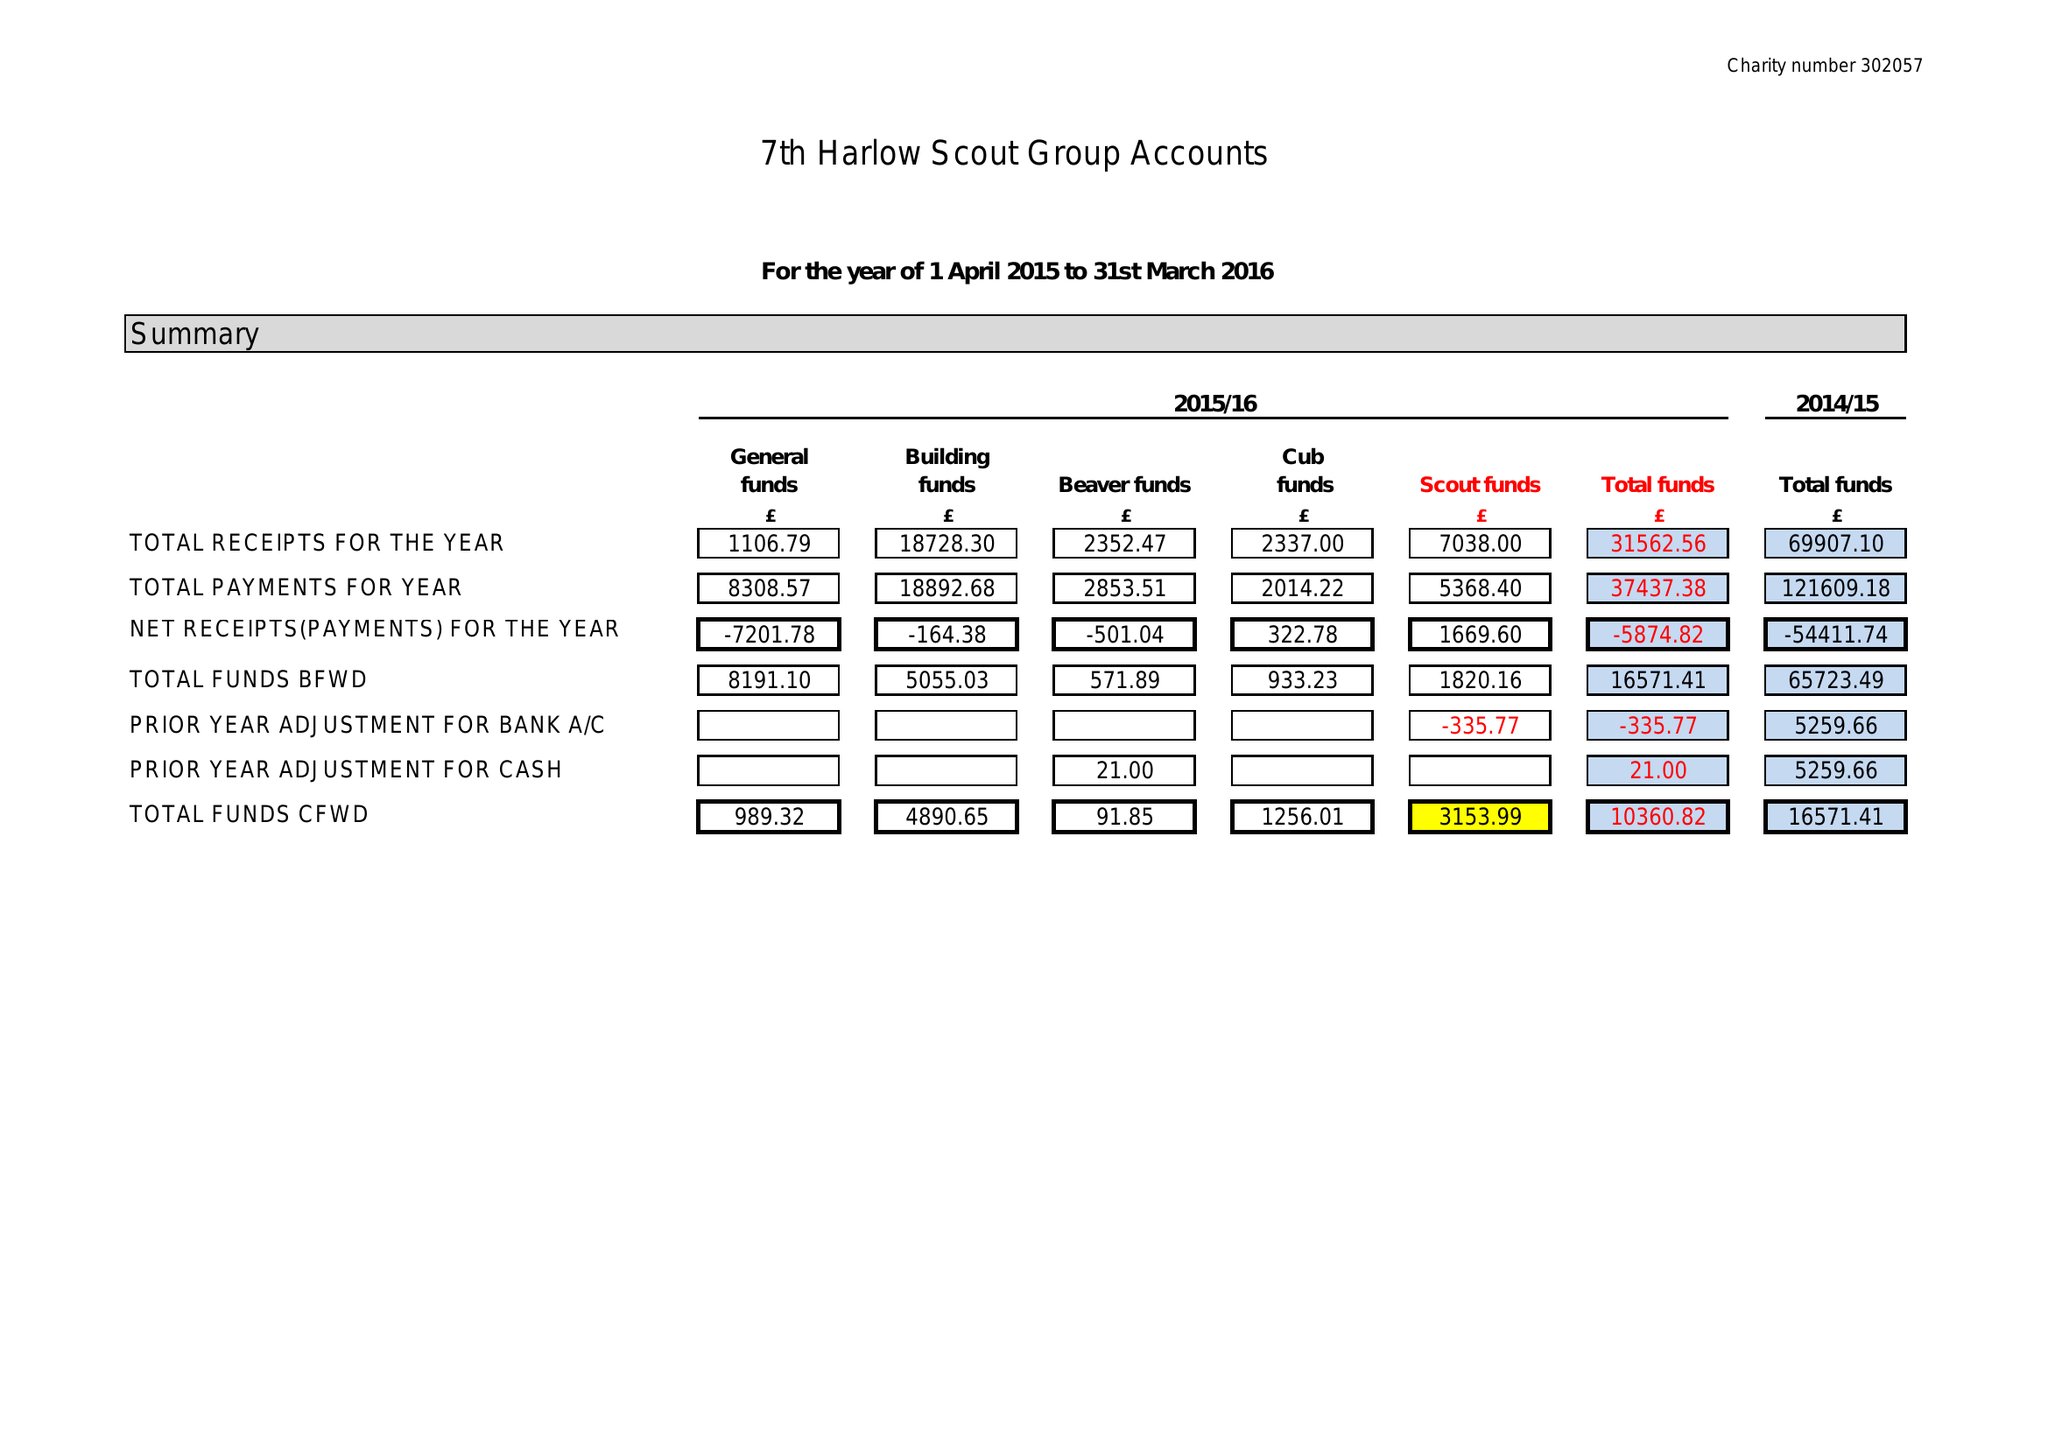What is the value for the charity_name?
Answer the question using a single word or phrase. 7th Harlow Scout Group 